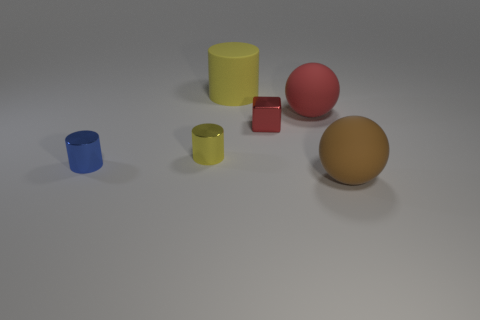Is there any other thing that has the same size as the yellow metallic cylinder?
Provide a short and direct response. Yes. There is a large object that is in front of the tiny red thing; is it the same shape as the small shiny thing that is right of the large yellow rubber cylinder?
Keep it short and to the point. No. What size is the brown sphere?
Make the answer very short. Large. What material is the big sphere that is behind the matte sphere that is in front of the small metallic object that is behind the small yellow cylinder?
Offer a very short reply. Rubber. How many other things are the same color as the large cylinder?
Your answer should be compact. 1. What number of yellow things are either large matte cylinders or big metallic things?
Your answer should be compact. 1. What is the yellow object that is in front of the yellow rubber cylinder made of?
Provide a short and direct response. Metal. Do the thing to the left of the tiny yellow thing and the tiny yellow cylinder have the same material?
Make the answer very short. Yes. What is the shape of the tiny yellow object?
Provide a short and direct response. Cylinder. How many metal cubes are right of the yellow thing that is in front of the yellow cylinder that is on the right side of the yellow metallic thing?
Make the answer very short. 1. 